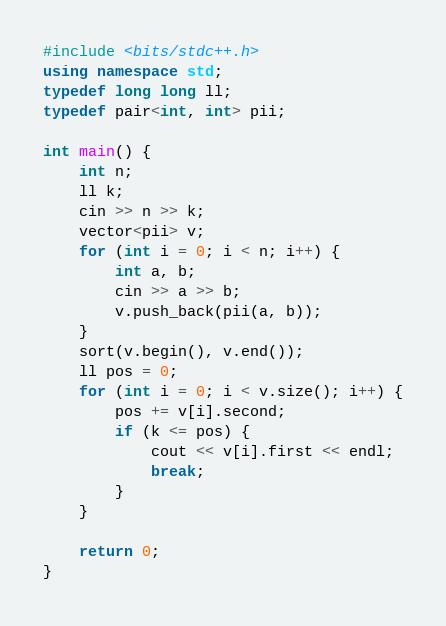Convert code to text. <code><loc_0><loc_0><loc_500><loc_500><_C++_>#include <bits/stdc++.h>
using namespace std;
typedef long long ll;
typedef pair<int, int> pii;

int main() {
    int n;
    ll k;
    cin >> n >> k;
    vector<pii> v;
    for (int i = 0; i < n; i++) {
        int a, b;
        cin >> a >> b;
        v.push_back(pii(a, b));
    }
    sort(v.begin(), v.end());
    ll pos = 0;
    for (int i = 0; i < v.size(); i++) {
        pos += v[i].second;
        if (k <= pos) {
            cout << v[i].first << endl;
            break;
        }
    }

    return 0;
}
</code> 